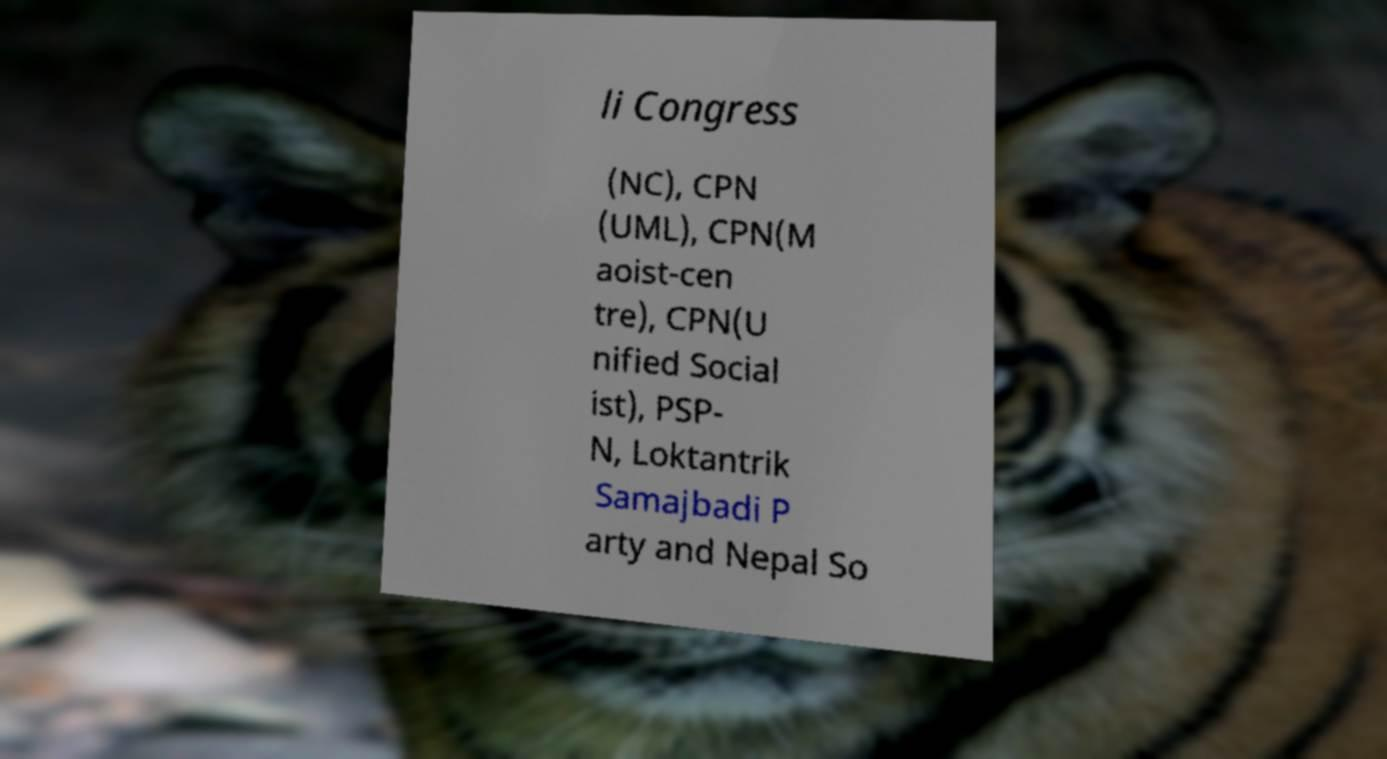I need the written content from this picture converted into text. Can you do that? li Congress (NC), CPN (UML), CPN(M aoist-cen tre), CPN(U nified Social ist), PSP- N, Loktantrik Samajbadi P arty and Nepal So 